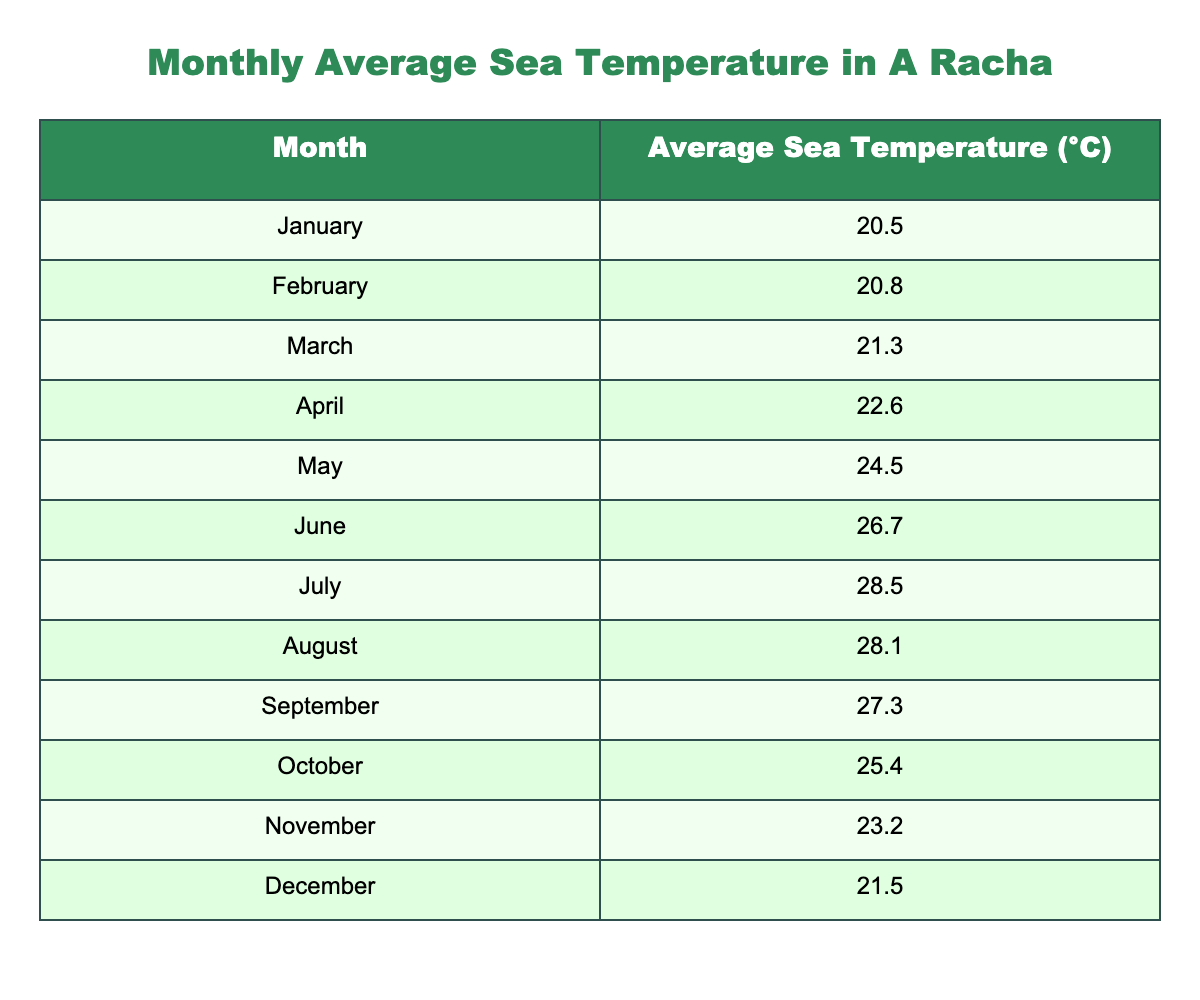What is the average sea temperature in July? The table shows that the average sea temperature in July is listed as 28.5°C.
Answer: 28.5°C Which month has the highest average sea temperature? By reviewing the table, July, with an average sea temperature of 28.5°C, has the highest value compared to all other months.
Answer: July What is the temperature difference between the highest and lowest values? The highest average sea temperature is in July (28.5°C), and the lowest is in January (20.5°C). The difference is 28.5°C - 20.5°C = 8°C.
Answer: 8°C Is the average sea temperature in October higher than in March? According to the table, October has an average temperature of 25.4°C while March is at 21.3°C. Since 25.4°C > 21.3°C, the statement is true.
Answer: Yes What is the average sea temperature for the summer months (June, July, August)? The average temperature for June is 26.7°C, July is 28.5°C, and August is 28.1°C. To find the average for summer months, we sum these temperatures: 26.7°C + 28.5°C + 28.1°C = 83.3°C, and then divide by 3, resulting in 83.3°C / 3 = 27.77°C.
Answer: 27.77°C Which month has a temperature below 22°C? Reviewing the table, January (20.5°C), February (20.8°C), and March (21.3°C) are all below 22°C.
Answer: January, February, March Is the average sea temperature in December higher than in November? The table shows December's average temperature is 21.5°C and November's is 23.2°C. Thus, 21.5°C < 23.2°C means December's temperature is not higher.
Answer: No What is the sum of the average sea temperatures from January to March? The average temperatures for January, February, and March are 20.5°C, 20.8°C, and 21.3°C respectively. Summing these gives 20.5°C + 20.8°C + 21.3°C = 62.6°C.
Answer: 62.6°C 